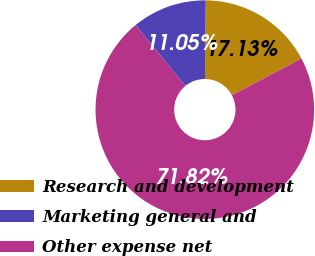Convert chart. <chart><loc_0><loc_0><loc_500><loc_500><pie_chart><fcel>Research and development<fcel>Marketing general and<fcel>Other expense net<nl><fcel>17.13%<fcel>11.05%<fcel>71.82%<nl></chart> 